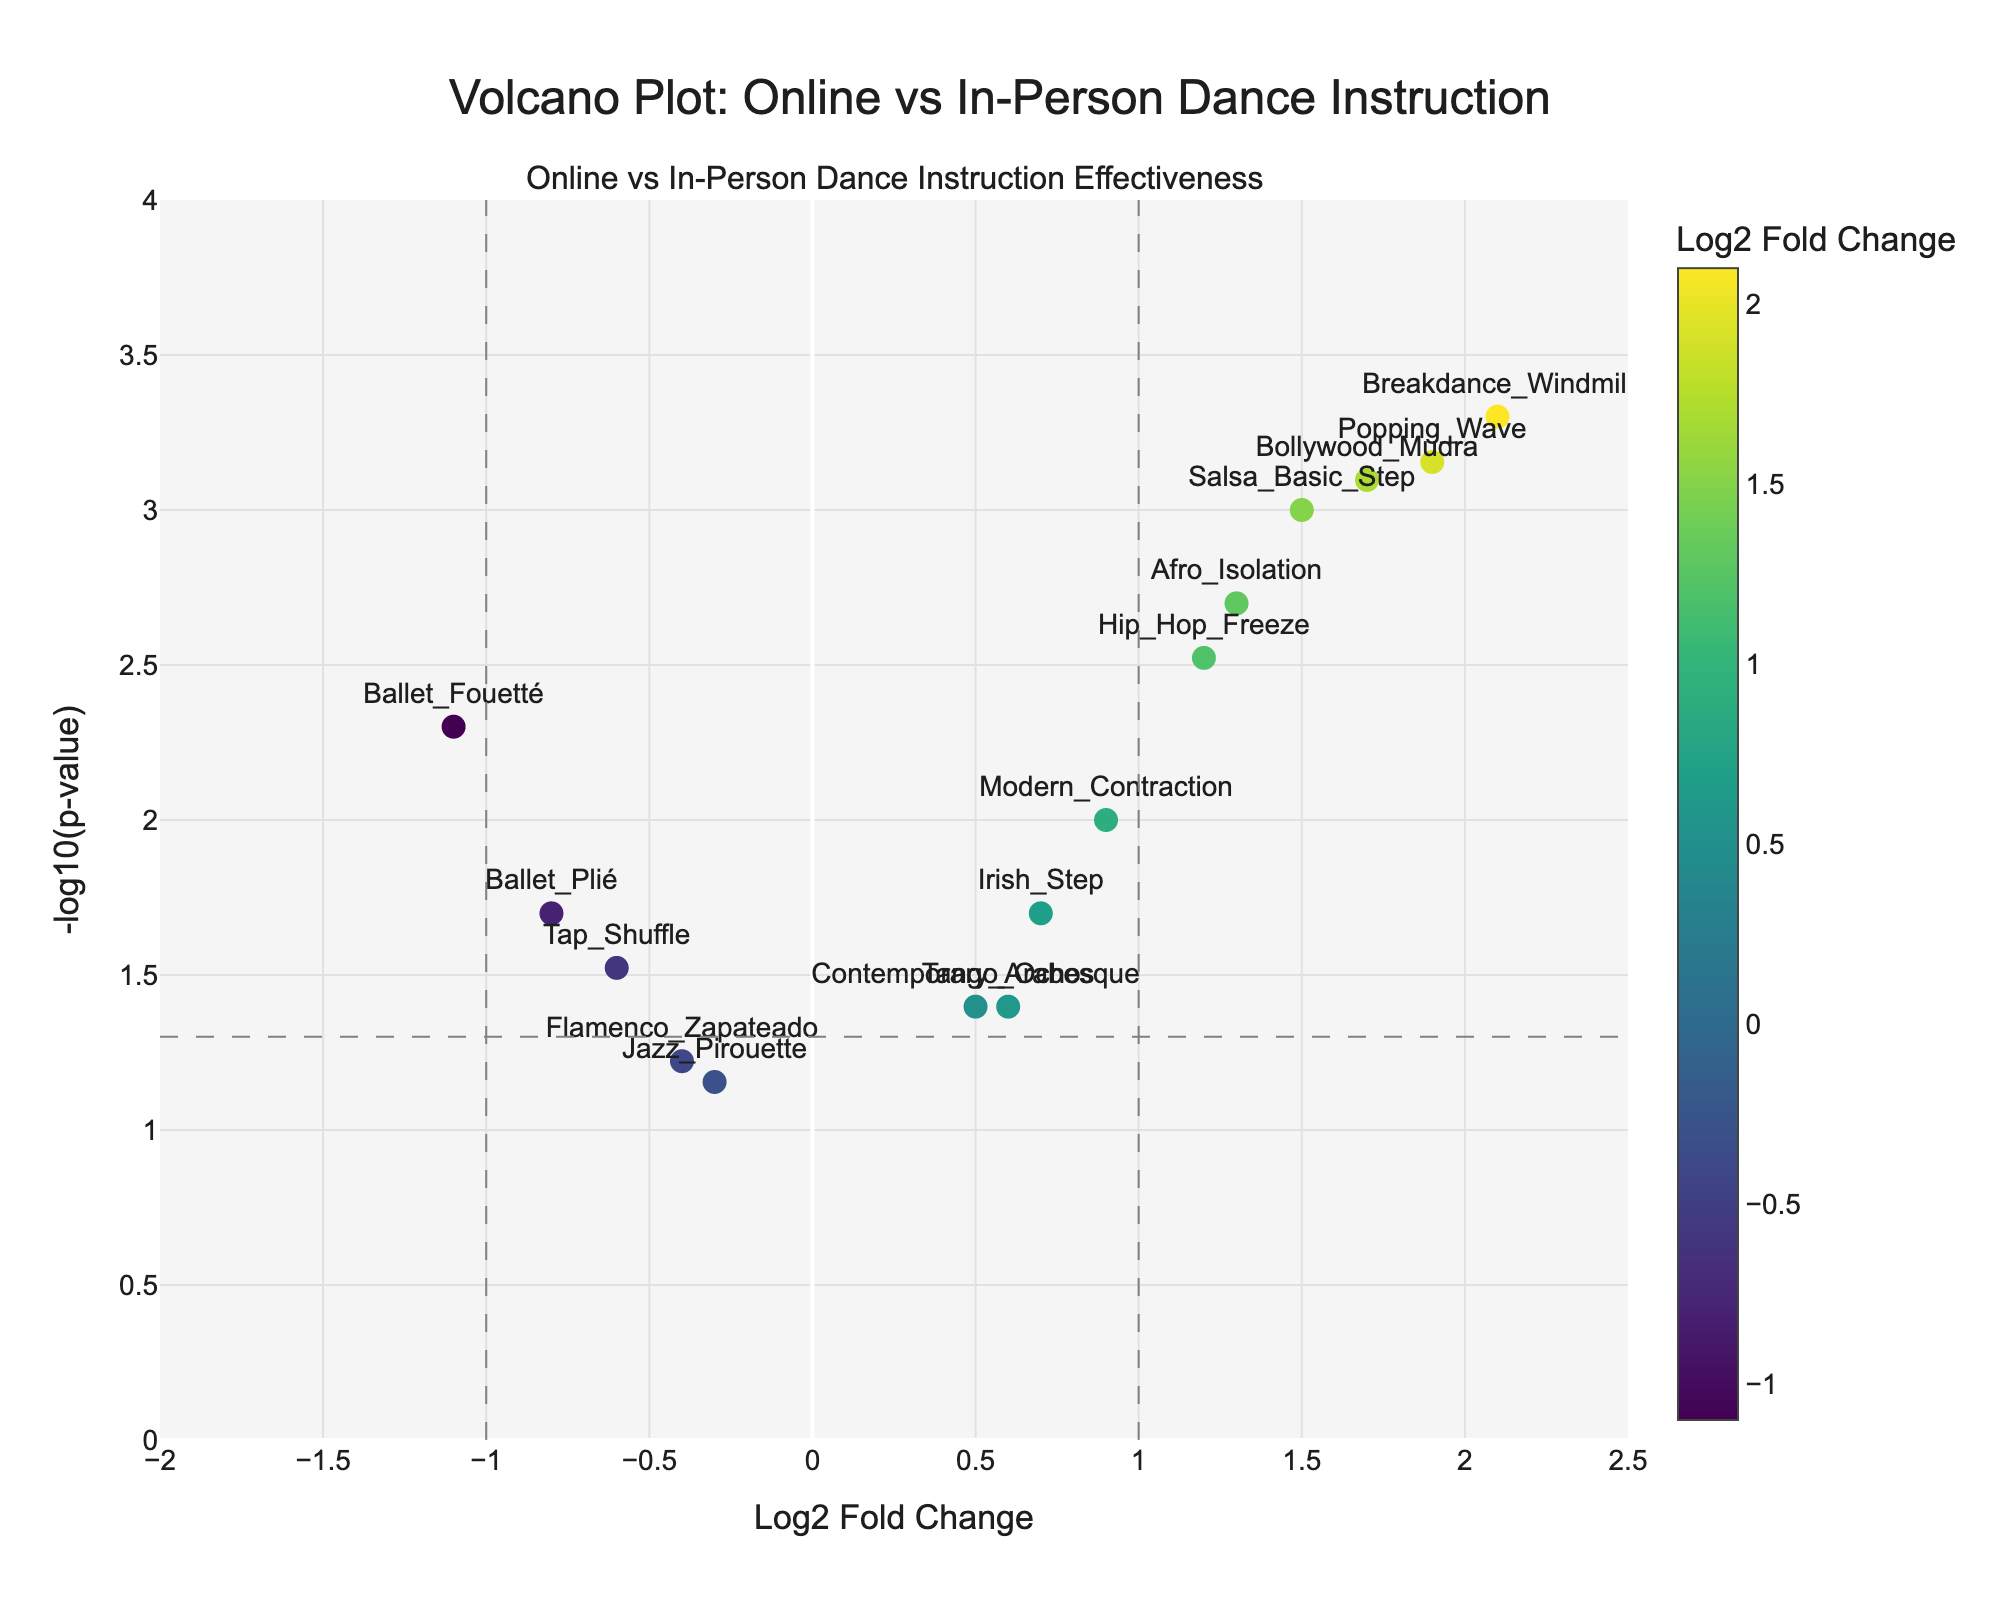What is the title of the plot? The title is typically at the top of the figure, positioned in the center in slightly larger font size.
Answer: Volcano Plot: Online vs In-Person Dance Instruction How many dance moves appear to favor online instruction based on the Log2 Fold Change? Any point to the right of the vertical line at Log2 Fold Change = 0. Online-favoring moves are those with positive Log2 Fold Change values. Count these points.
Answer: 8 Which dance move has the highest -log10(p-value) and what does it imply? Identify the point which is at the highest vertical position. Then, look at the label to identify the associated dance move.
Answer: Breakdance Windmill. It implies this move has the most statistically significant difference between online and in-person instruction What are the Log2 Fold Change and p-value for Salsa Basic Step? Locate the label "Salsa Basic Step" on the plot, the x-coordinate represents Log2 Fold Change and the height (-log10(p)) can be used to find the p-value.
Answer: Log2 Fold Change: 1.5, p-value: 0.001 Which dance move has the most negative Log2 Fold Change, suggesting it favors in-person instruction the most? Find the point furthest to the left, note its label.
Answer: Ballet Fouetté Compare the significance of Afro Isolation and Irish Step; which one is more significant? Compare the -log10(p-value), the higher the value, the more significant. Locate Afro Isolation and Irish Step, compare their y-coordinates.
Answer: Afro Isolation On the figure, what is represented by the vertical and horizontal dashed lines? Vertical dashed lines typically represent threshold values of Log2 Fold Change (-1 and 1), and the horizontal dashed line represents the threshold for p-value (0.05).
Answer: Thresholds for Log2 Fold Change and p-value significance How many dance moves have both a Log2 Fold Change greater than 1 and a p-value less than 0.01? Count points in the region to the right of Log2 Fold Change = 1 and above -log10(p) = 2.
Answer: 4 What does a higher Log2 Fold Change value indicate in context of online vs in-person dance instruction? A higher Log2 Fold Change value suggests that the dance move is more effectively taught online compared to in-person.
Answer: Indicates better effectiveness online 